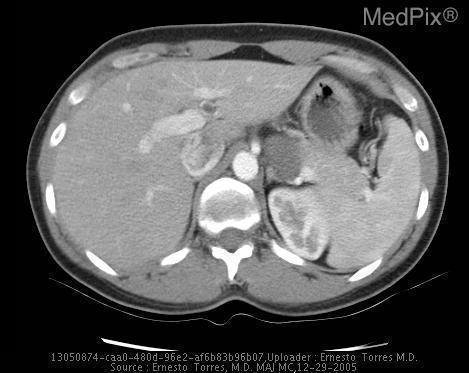Where is the spleen located?
Short answer required. On the left. Is the spleen present?
Give a very brief answer. Yes. Where in relation to the mass is the left kidney located in this image?
Write a very short answer. Posteriorly. Where is the mass located in relation to the left kidney?
Give a very brief answer. Posteriorly. Is the liver normal?
Keep it brief. Yes. Is a ring enhancing lesion present in the right lobe of the liver?
Be succinct. No. Is the lesion in this image more or less dense than the surrounding tissue?
Short answer required. Less dense. What is denser, the lesion or the surrounding tissue?
Keep it brief. The surrounding tissue. 